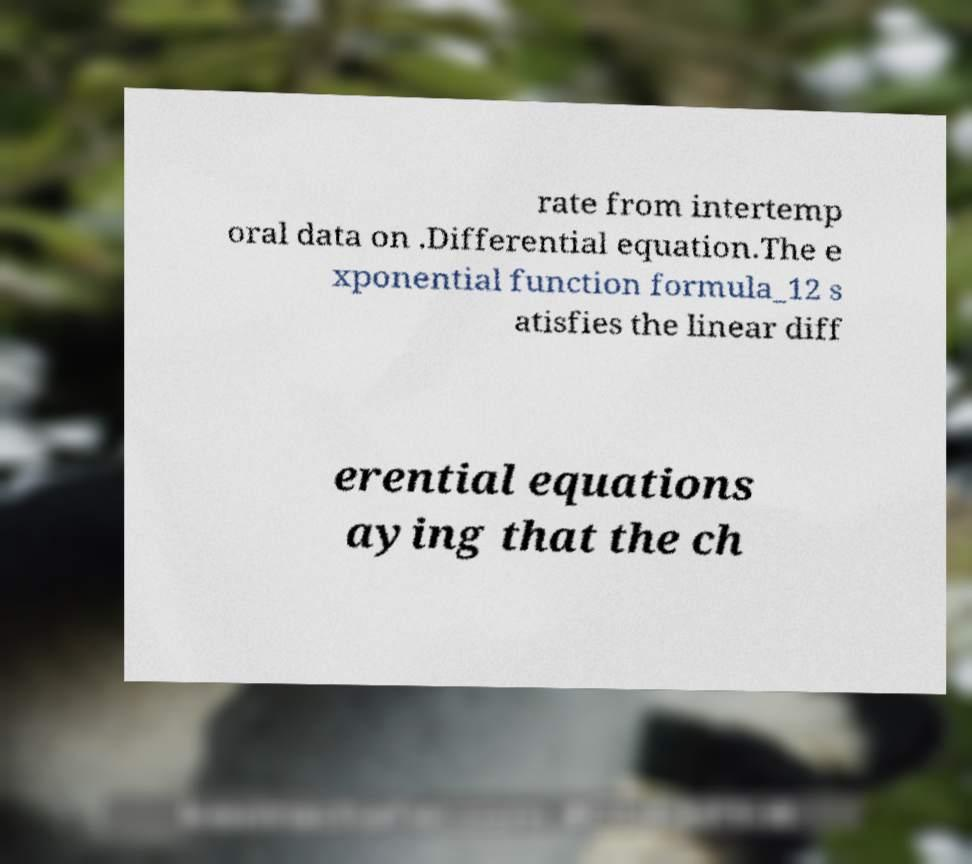Could you extract and type out the text from this image? rate from intertemp oral data on .Differential equation.The e xponential function formula_12 s atisfies the linear diff erential equations aying that the ch 